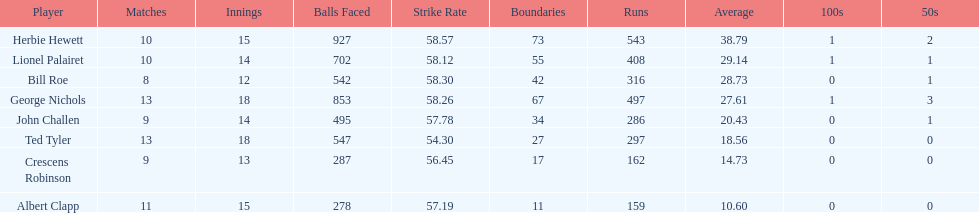Would you mind parsing the complete table? {'header': ['Player', 'Matches', 'Innings', 'Balls Faced', 'Strike Rate', 'Boundaries', 'Runs', 'Average', '100s', '50s'], 'rows': [['Herbie Hewett', '10', '15', '927', '58.57', '73', '543', '38.79', '1', '2'], ['Lionel Palairet', '10', '14', '702', '58.12', '55', '408', '29.14', '1', '1'], ['Bill Roe', '8', '12', '542', '58.30', '42', '316', '28.73', '0', '1'], ['George Nichols', '13', '18', '853', '58.26', '67', '497', '27.61', '1', '3'], ['John Challen', '9', '14', '495', '57.78', '34', '286', '20.43', '0', '1'], ['Ted Tyler', '13', '18', '547', '54.30', '27', '297', '18.56', '0', '0'], ['Crescens Robinson', '9', '13', '287', '56.45', '17', '162', '14.73', '0', '0'], ['Albert Clapp', '11', '15', '278', '57.19', '11', '159', '10.60', '0', '0']]} How many innings did bill and ted have in total? 30. 